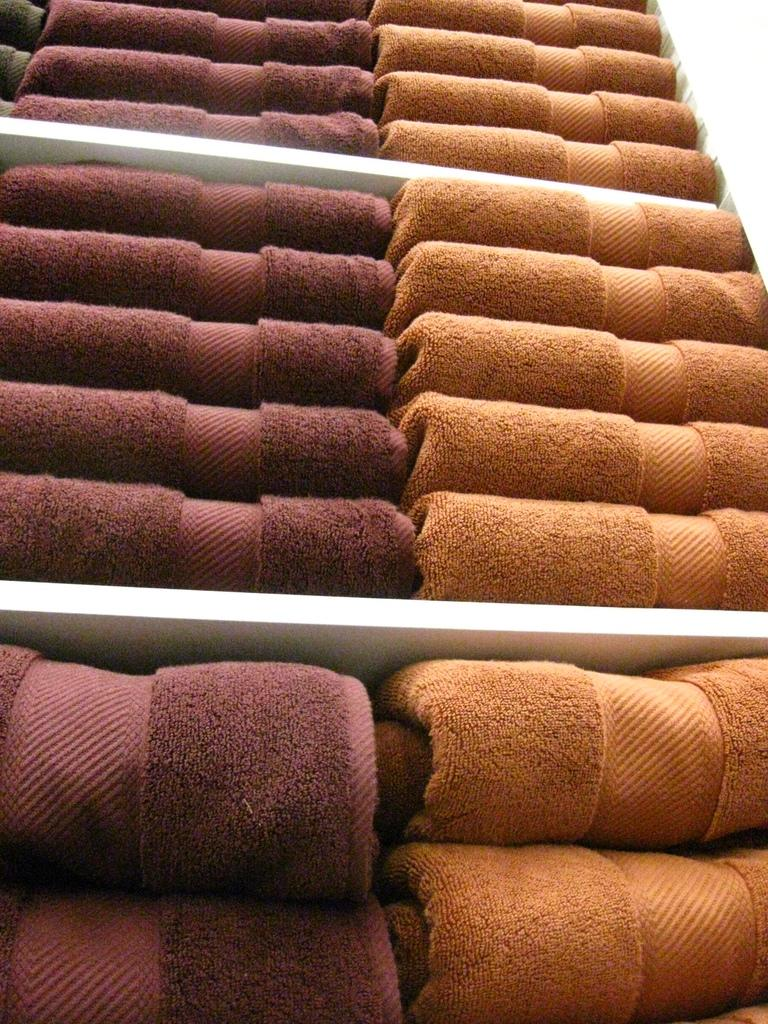What can be seen in the image related to towels? There are towels with two different colors in the image. How are the towels arranged in the image? The towels are placed in racks. What type of stage can be seen in the image? There is no stage present in the image; it features towels placed in racks. Are there any locks visible on the towels in the image? There are no locks visible on the towels in the image. 